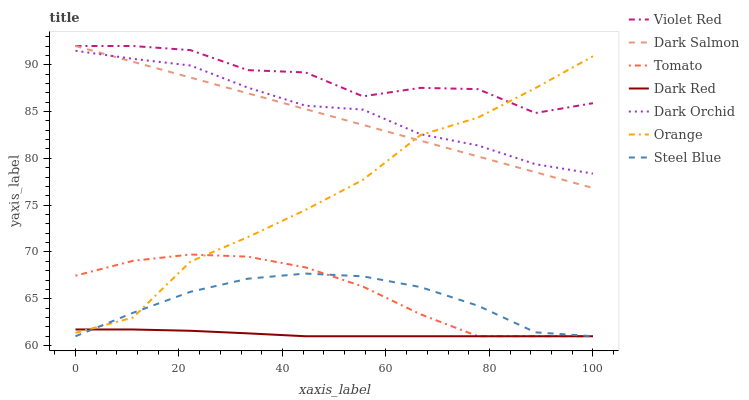Does Dark Red have the minimum area under the curve?
Answer yes or no. Yes. Does Violet Red have the maximum area under the curve?
Answer yes or no. Yes. Does Violet Red have the minimum area under the curve?
Answer yes or no. No. Does Dark Red have the maximum area under the curve?
Answer yes or no. No. Is Dark Salmon the smoothest?
Answer yes or no. Yes. Is Violet Red the roughest?
Answer yes or no. Yes. Is Dark Red the smoothest?
Answer yes or no. No. Is Dark Red the roughest?
Answer yes or no. No. Does Tomato have the lowest value?
Answer yes or no. Yes. Does Violet Red have the lowest value?
Answer yes or no. No. Does Dark Salmon have the highest value?
Answer yes or no. Yes. Does Dark Red have the highest value?
Answer yes or no. No. Is Steel Blue less than Violet Red?
Answer yes or no. Yes. Is Dark Orchid greater than Steel Blue?
Answer yes or no. Yes. Does Orange intersect Tomato?
Answer yes or no. Yes. Is Orange less than Tomato?
Answer yes or no. No. Is Orange greater than Tomato?
Answer yes or no. No. Does Steel Blue intersect Violet Red?
Answer yes or no. No. 